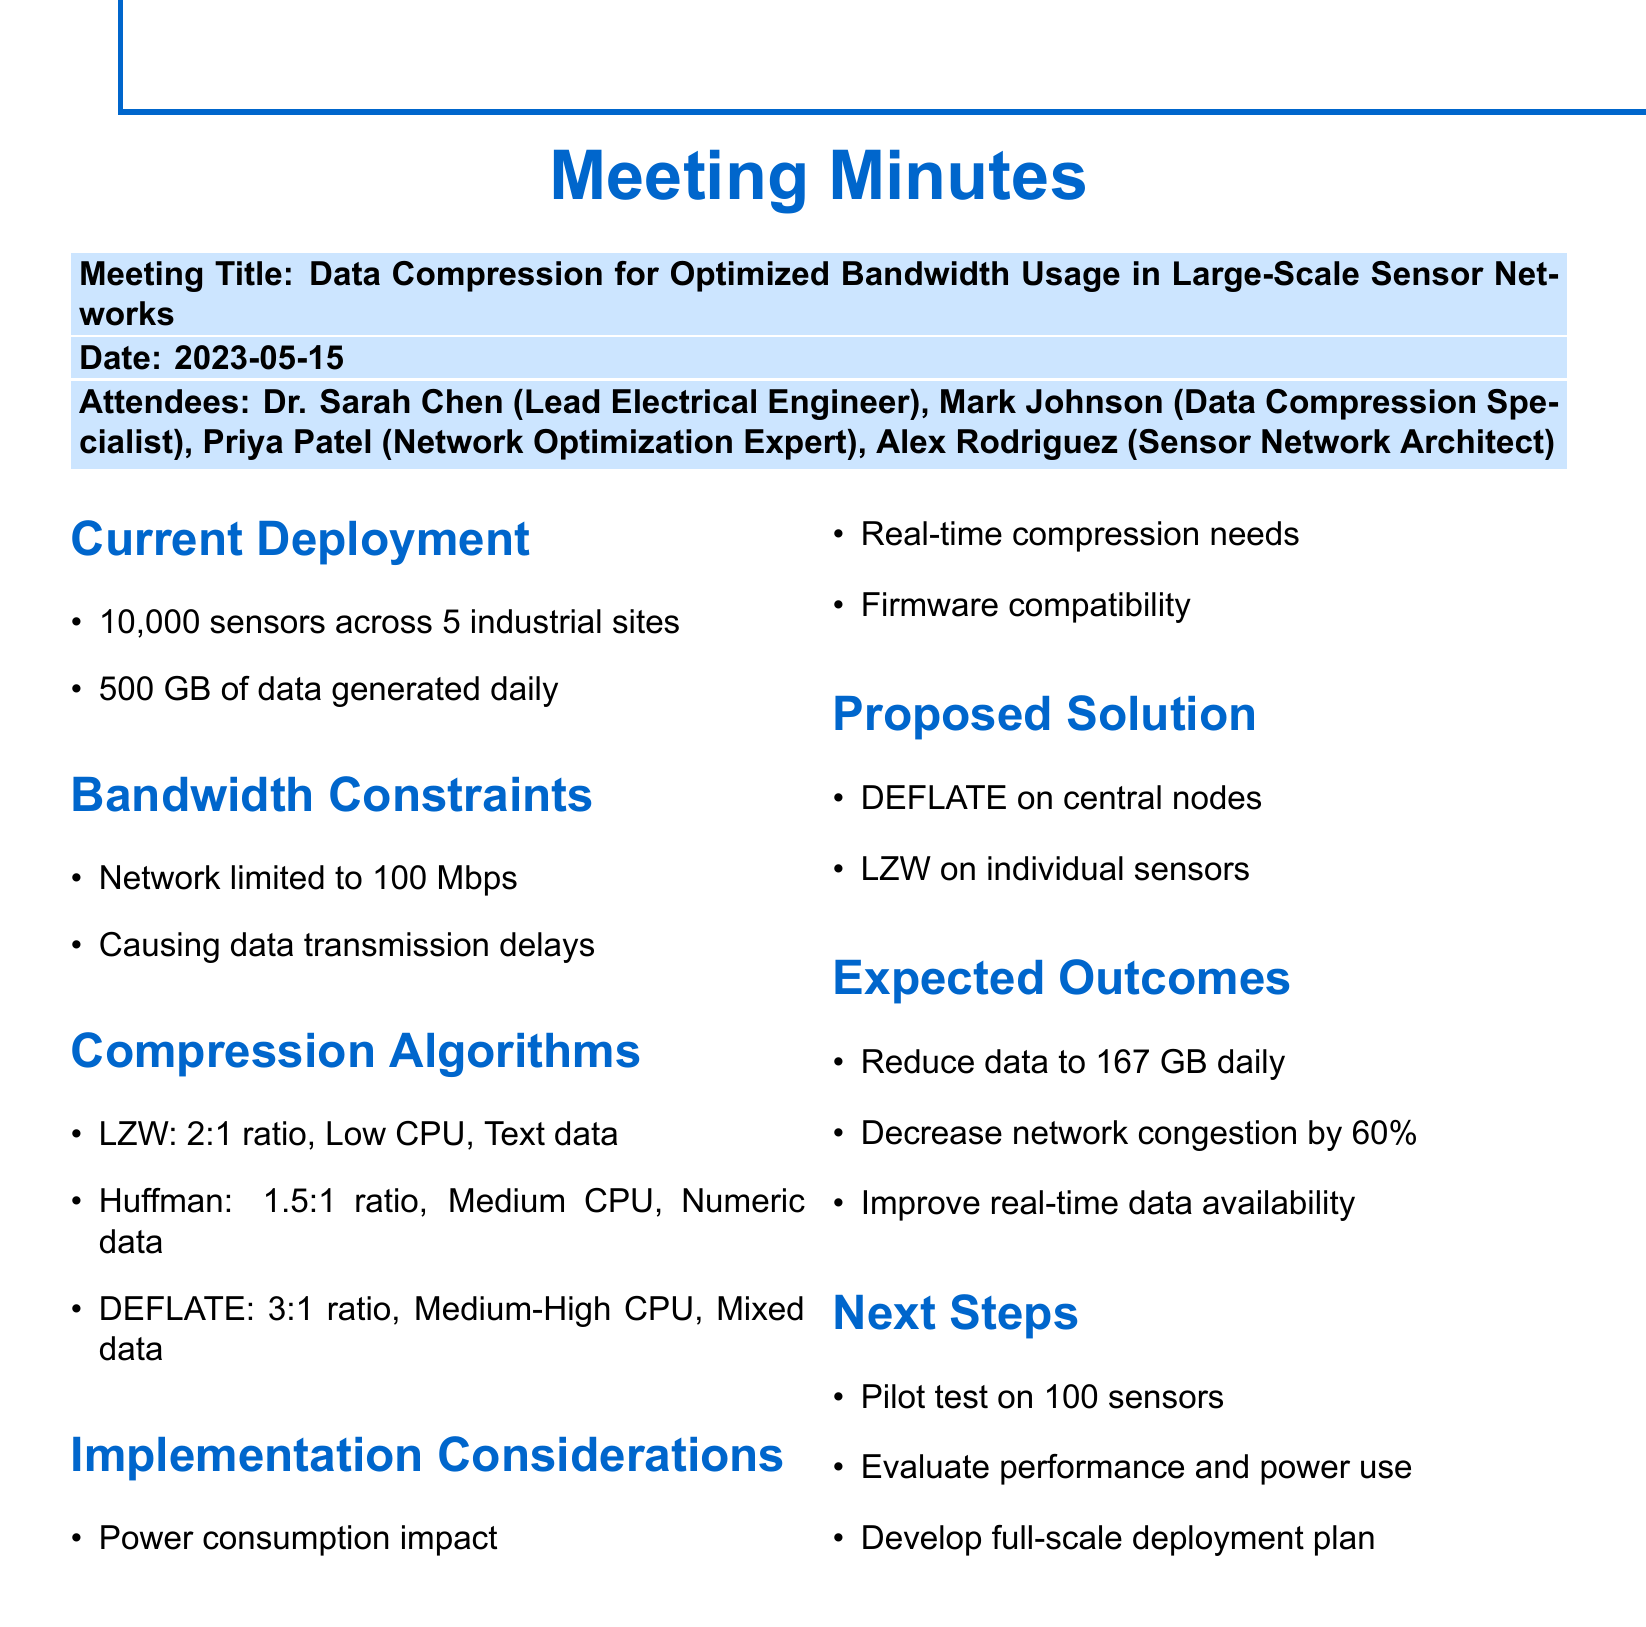What is the meeting title? The title of the meeting is explicitly stated in the document.
Answer: Data Compression for Optimized Bandwidth Usage in Large-Scale Sensor Networks When was the meeting held? The date of the meeting is provided clearly within the document.
Answer: 2023-05-15 How many sensors are deployed across the sites? The document states the total number of sensors deployed.
Answer: 10,000 What is the current bandwidth limit? The document specifies the limitations of the current network infrastructure.
Answer: 100 Mbps Which compression algorithm has the highest compression ratio? The document lists various algorithms along with their compression ratios for comparison.
Answer: DEFLATE What is the expected data reduction after implementing the proposed solution? The document mentions the projected reduction in daily data transmission.
Answer: 167 GB What action is planned for the next steps? The document outlines a set of actions that are to be taken following the meeting.
Answer: Conduct pilot test on 100 sensors Which compression algorithm is suggested for individual sensors? The document details the proposed application of the algorithms in the sensor network.
Answer: LZW What is the main focus of the analysis discussed in the meeting? The document summarizes the key topics addressed during the discussion.
Answer: Compression Algorithm Analysis 